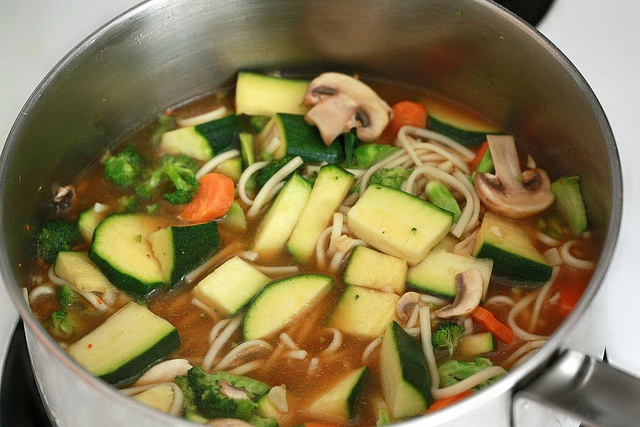Describe the objects in this image and their specific colors. I can see broccoli in darkgray, darkgreen, olive, and black tones, broccoli in darkgray, olive, and darkgreen tones, carrot in darkgray, red, orange, and brown tones, broccoli in darkgray, olive, and tan tones, and broccoli in darkgray, darkgreen, and black tones in this image. 